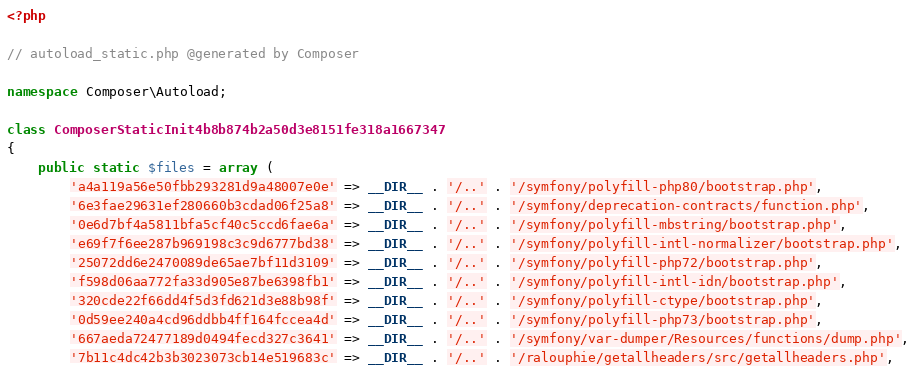Convert code to text. <code><loc_0><loc_0><loc_500><loc_500><_PHP_><?php

// autoload_static.php @generated by Composer

namespace Composer\Autoload;

class ComposerStaticInit4b8b874b2a50d3e8151fe318a1667347
{
    public static $files = array (
        'a4a119a56e50fbb293281d9a48007e0e' => __DIR__ . '/..' . '/symfony/polyfill-php80/bootstrap.php',
        '6e3fae29631ef280660b3cdad06f25a8' => __DIR__ . '/..' . '/symfony/deprecation-contracts/function.php',
        '0e6d7bf4a5811bfa5cf40c5ccd6fae6a' => __DIR__ . '/..' . '/symfony/polyfill-mbstring/bootstrap.php',
        'e69f7f6ee287b969198c3c9d6777bd38' => __DIR__ . '/..' . '/symfony/polyfill-intl-normalizer/bootstrap.php',
        '25072dd6e2470089de65ae7bf11d3109' => __DIR__ . '/..' . '/symfony/polyfill-php72/bootstrap.php',
        'f598d06aa772fa33d905e87be6398fb1' => __DIR__ . '/..' . '/symfony/polyfill-intl-idn/bootstrap.php',
        '320cde22f66dd4f5d3fd621d3e88b98f' => __DIR__ . '/..' . '/symfony/polyfill-ctype/bootstrap.php',
        '0d59ee240a4cd96ddbb4ff164fccea4d' => __DIR__ . '/..' . '/symfony/polyfill-php73/bootstrap.php',
        '667aeda72477189d0494fecd327c3641' => __DIR__ . '/..' . '/symfony/var-dumper/Resources/functions/dump.php',
        '7b11c4dc42b3b3023073cb14e519683c' => __DIR__ . '/..' . '/ralouphie/getallheaders/src/getallheaders.php',</code> 